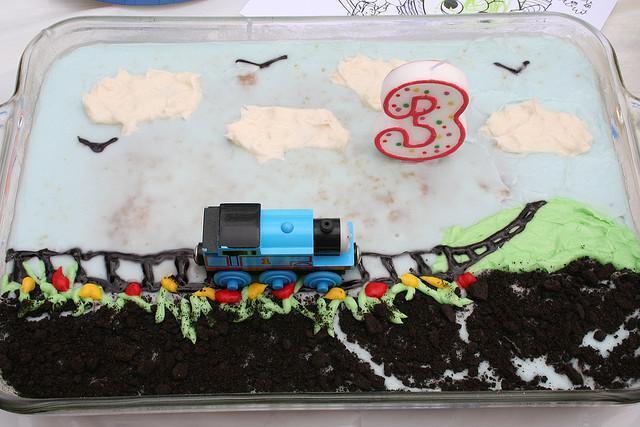How many candles are on the cake?
Give a very brief answer. 1. How many people are going downhill?
Give a very brief answer. 0. 